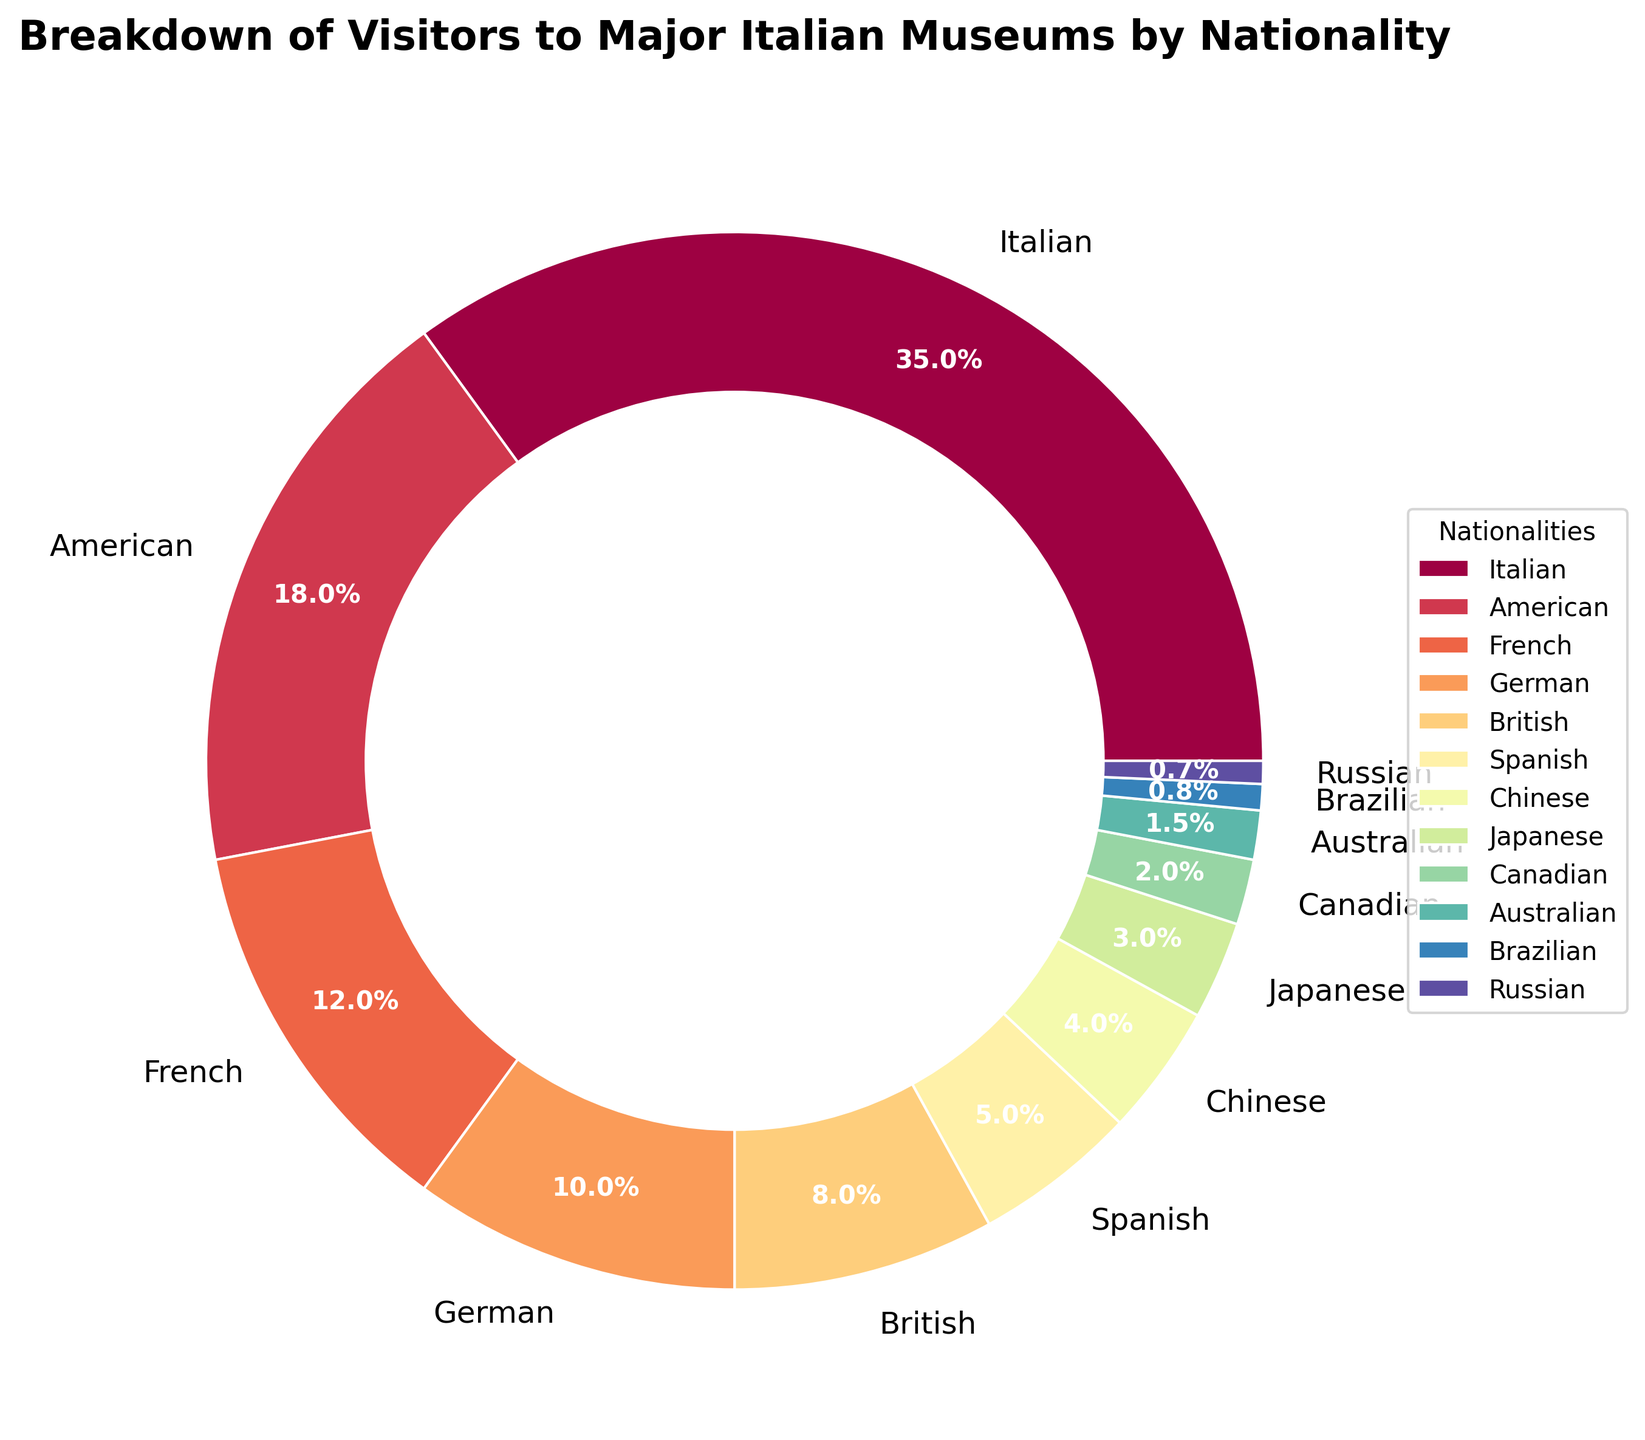Which nationality has the highest percentage of visitors to major Italian museums? The pie chart's largest segment is labeled "Italian" with 35%
Answer: Italian What is the combined percentage of visitors from American and German nationalities? The pie chart shows Americans at 18% and Germans at 10%. Adding these together results in 18% + 10% = 28%
Answer: 28% How many nationalities have a percentage of visitors that is less than 5%? The pie chart segments labeled Spanish (5%), Chinese (4%), Japanese (3%), Canadian (2%), Australian (1.5%), Brazilian (0.8%), and Russian (0.7%) are all less than 5%. There are 7 such nationalities
Answer: 7 Compare the percentage of visitors from France and the United Kingdom. Which one has a higher percentage? The pie chart shows that French visitors account for 12% while British visitors account for 8%. Therefore, France has a higher percentage
Answer: France Which nationality's segment is visually the smallest in the pie chart? The segment labeled "Russian" with 0.7% is the smallest on the pie chart
Answer: Russian Calculate the difference in the percentage of visitors between the Italian and the second-highest nationality. Italians have 35% and Americans have 18%, so the difference is 35% - 18% = 17%
Answer: 17% What is the total percentage of visitors from non-European countries? Non-European nationalities listed are American (18%), Chinese (4%), Japanese (3%), Canadian (2%), Australian (1.5%), Brazilian (0.8%), and Russian (0.7%). Summing these: 18% + 4% + 3% + 2% + 1.5% + 0.8% + 0.7% = 30%
Answer: 30% What percentage of visitors are from Western European countries (Italy, France, Germany, United Kingdom, and Spain)? Adding the percentages for Italy (35%), France (12%), Germany (10%), United Kingdom (8%), and Spain (5%), we get 35% + 12% + 10% + 8% + 5% = 70%
Answer: 70% If you combined the percentages of visitors from Brazilian and Russian nationalities, would the total be more or less than 1%? Brazilian visitors are at 0.8% and Russian visitors are at 0.7%. Combined, this is 0.8% + 0.7% = 1.5%, which is more than 1%
Answer: More 